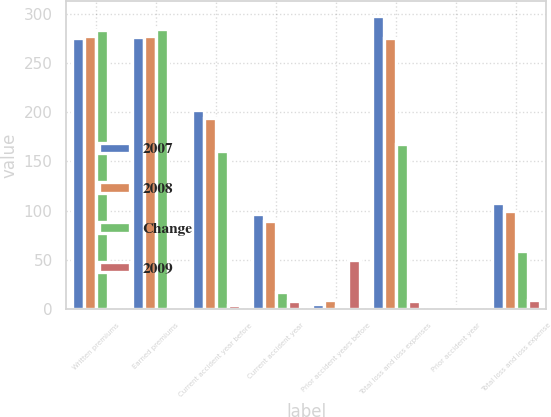Convert chart to OTSL. <chart><loc_0><loc_0><loc_500><loc_500><stacked_bar_chart><ecel><fcel>Written premiums<fcel>Earned premiums<fcel>Current accident year before<fcel>Current accident year<fcel>Prior accident years before<fcel>Total loss and loss expenses<fcel>Prior accident year<fcel>Total loss and loss expense<nl><fcel>2007<fcel>275<fcel>276<fcel>202<fcel>96<fcel>5<fcel>298<fcel>1.7<fcel>107.8<nl><fcel>2008<fcel>277<fcel>277<fcel>194<fcel>89<fcel>9<fcel>275<fcel>0.4<fcel>99.2<nl><fcel>Change<fcel>284<fcel>285<fcel>161<fcel>17<fcel>3<fcel>168<fcel>2.5<fcel>59<nl><fcel>2009<fcel>0.6<fcel>0.4<fcel>4.1<fcel>7.8<fcel>49.7<fcel>8.3<fcel>1.3<fcel>8.6<nl></chart> 